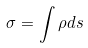Convert formula to latex. <formula><loc_0><loc_0><loc_500><loc_500>\sigma = \int \rho d s</formula> 